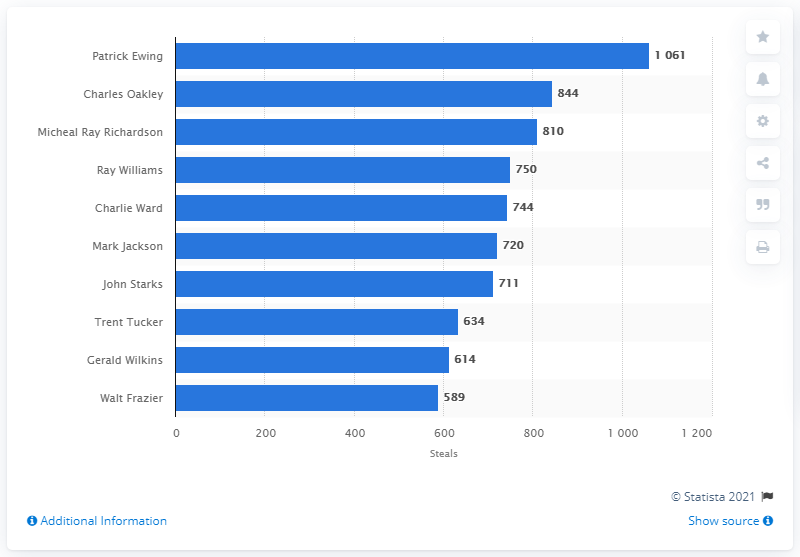Draw attention to some important aspects in this diagram. Patrick Ewing is the career steals leader of the New York Knicks. 